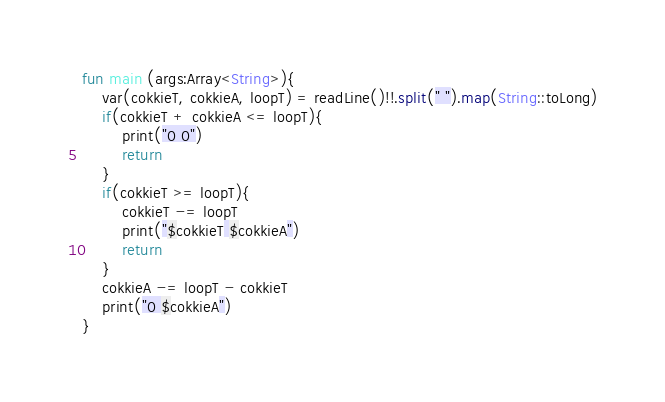<code> <loc_0><loc_0><loc_500><loc_500><_Kotlin_>fun main (args:Array<String>){
    var(cokkieT, cokkieA, loopT) = readLine()!!.split(" ").map(String::toLong)
    if(cokkieT + cokkieA <= loopT){
        print("0 0")
        return
    }
    if(cokkieT >= loopT){
        cokkieT -= loopT
        print("$cokkieT $cokkieA")
        return
    }
    cokkieA -= loopT - cokkieT
    print("0 $cokkieA")
}
</code> 